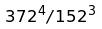<formula> <loc_0><loc_0><loc_500><loc_500>3 7 2 ^ { 4 } / 1 5 2 ^ { 3 }</formula> 